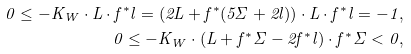<formula> <loc_0><loc_0><loc_500><loc_500>0 \leq - K _ { W } \cdot L \cdot f ^ { * } l = ( 2 L + f ^ { * } ( 5 \Sigma + 2 l ) ) \cdot L \cdot f ^ { * } l = - 1 , \\ 0 \leq - K _ { W } \cdot ( L + f ^ { * } \Sigma - 2 f ^ { * } l ) \cdot f ^ { * } \Sigma < 0 ,</formula> 